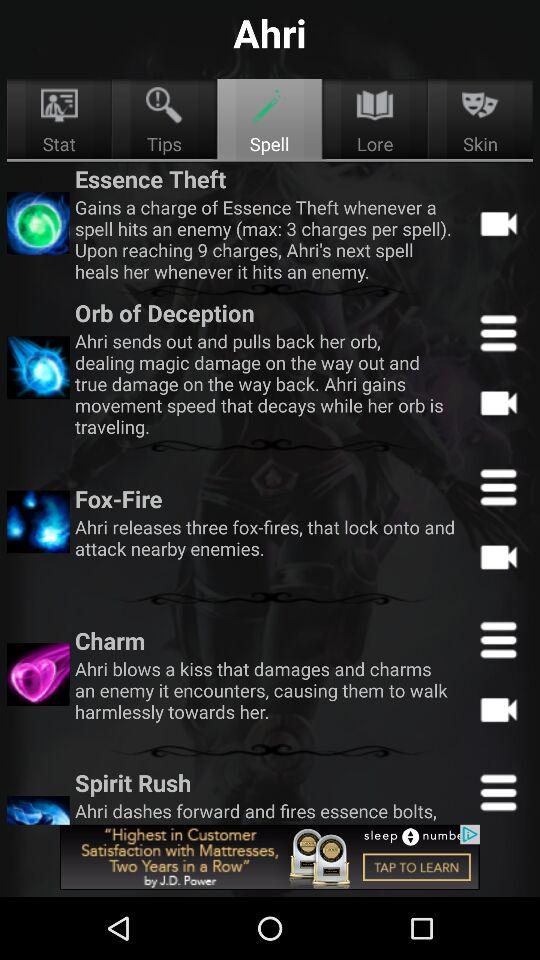What are the available options? The available options are "Stat", "Tips", "Spell", "Lore" and "Skin". 